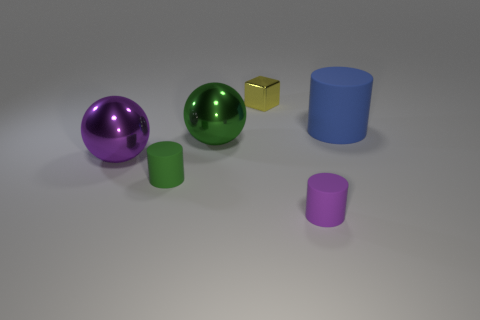Add 2 green metallic spheres. How many objects exist? 8 Subtract all spheres. How many objects are left? 4 Subtract all blue matte cylinders. Subtract all big balls. How many objects are left? 3 Add 3 green cylinders. How many green cylinders are left? 4 Add 4 big cyan rubber cylinders. How many big cyan rubber cylinders exist? 4 Subtract 0 brown cubes. How many objects are left? 6 